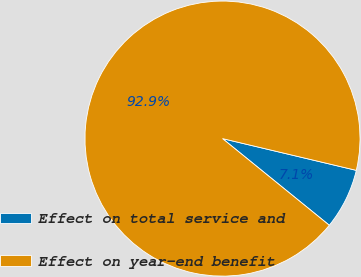<chart> <loc_0><loc_0><loc_500><loc_500><pie_chart><fcel>Effect on total service and<fcel>Effect on year-end benefit<nl><fcel>7.14%<fcel>92.86%<nl></chart> 